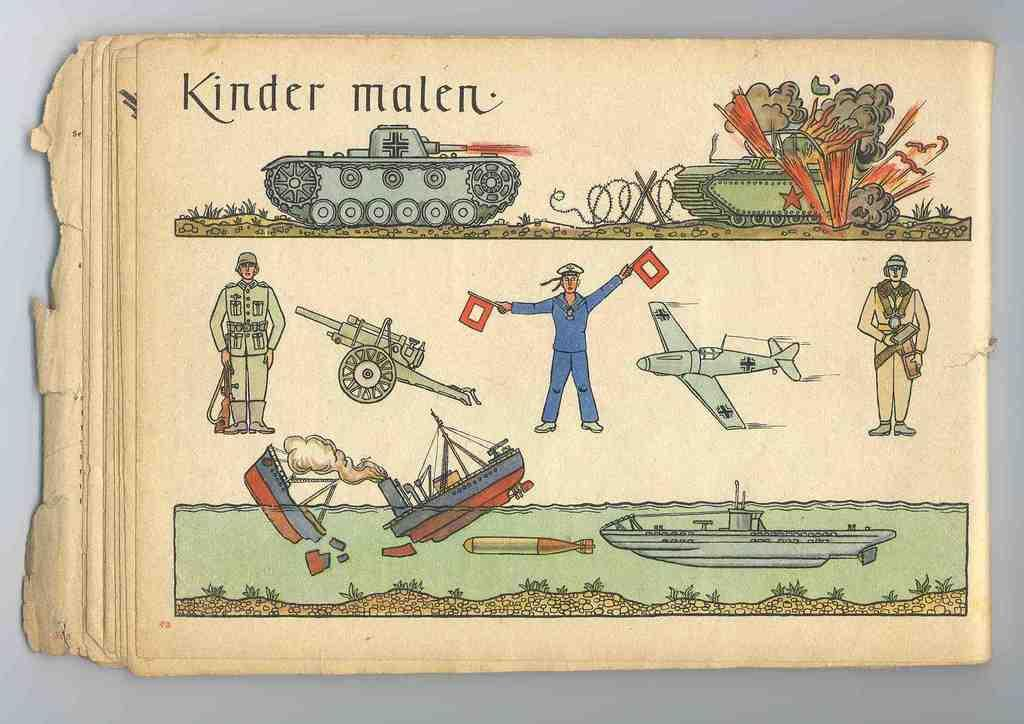What is located in the center of the image? There are papers in the center of the image. What can be found on the papers? The papers contain text. Who or what can be seen in the image? There are persons in the image. What else is present in the image besides the persons? There are boats and other objects in the image. What can be seen in the background of the image? There is a wall in the background of the image. Can you tell me how many legs are visible in the image? There is no information about legs in the image, as the focus is on the papers, persons, boats, and other objects. 